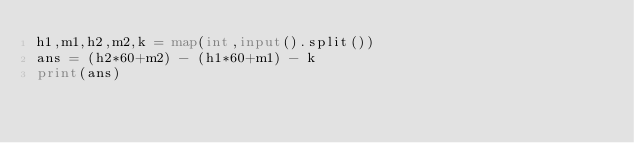Convert code to text. <code><loc_0><loc_0><loc_500><loc_500><_Python_>h1,m1,h2,m2,k = map(int,input().split())
ans = (h2*60+m2) - (h1*60+m1) - k
print(ans)</code> 